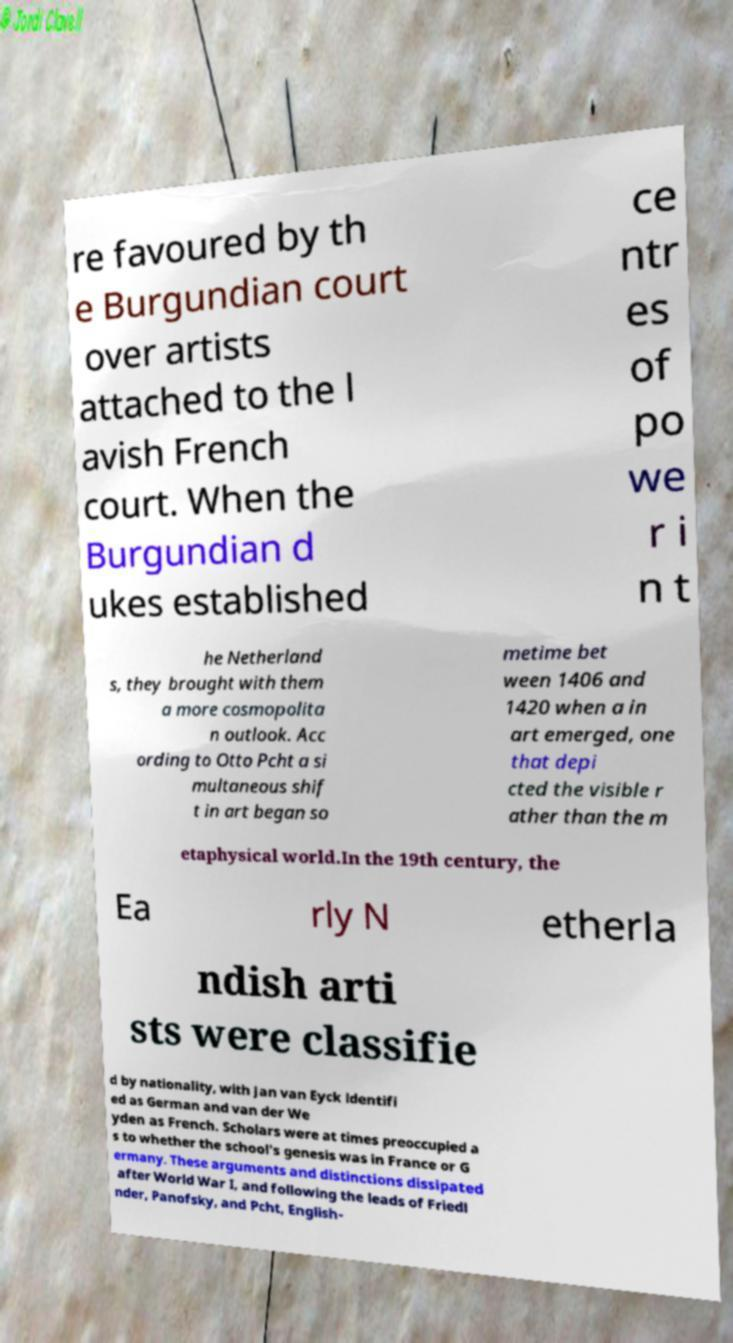Can you read and provide the text displayed in the image?This photo seems to have some interesting text. Can you extract and type it out for me? re favoured by th e Burgundian court over artists attached to the l avish French court. When the Burgundian d ukes established ce ntr es of po we r i n t he Netherland s, they brought with them a more cosmopolita n outlook. Acc ording to Otto Pcht a si multaneous shif t in art began so metime bet ween 1406 and 1420 when a in art emerged, one that depi cted the visible r ather than the m etaphysical world.In the 19th century, the Ea rly N etherla ndish arti sts were classifie d by nationality, with Jan van Eyck identifi ed as German and van der We yden as French. Scholars were at times preoccupied a s to whether the school's genesis was in France or G ermany. These arguments and distinctions dissipated after World War I, and following the leads of Friedl nder, Panofsky, and Pcht, English- 